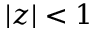<formula> <loc_0><loc_0><loc_500><loc_500>| z | < 1</formula> 